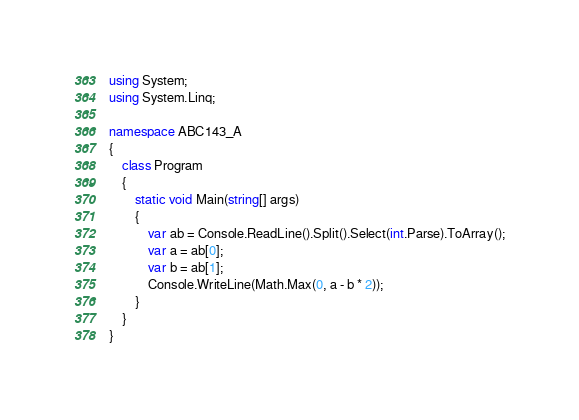Convert code to text. <code><loc_0><loc_0><loc_500><loc_500><_C#_>using System;
using System.Linq;

namespace ABC143_A
{
    class Program
    {
        static void Main(string[] args)
        {
            var ab = Console.ReadLine().Split().Select(int.Parse).ToArray();
            var a = ab[0];
            var b = ab[1];
            Console.WriteLine(Math.Max(0, a - b * 2));
        }
    }
}
</code> 